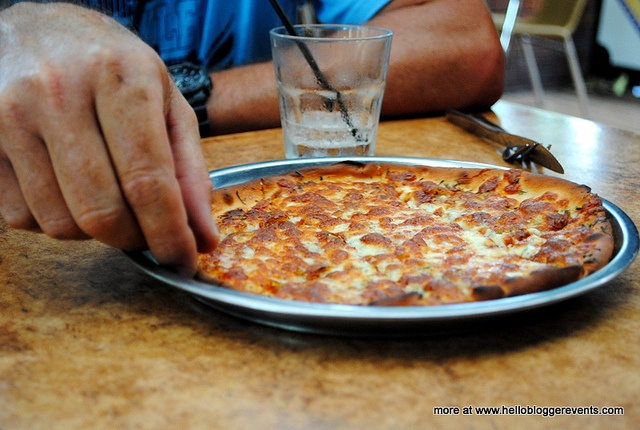Describe the objects in this image and their specific colors. I can see dining table in black, tan, and olive tones, people in black, gray, maroon, and darkgray tones, pizza in black, tan, salmon, and brown tones, cup in black, darkgray, and gray tones, and chair in black, gray, and olive tones in this image. 